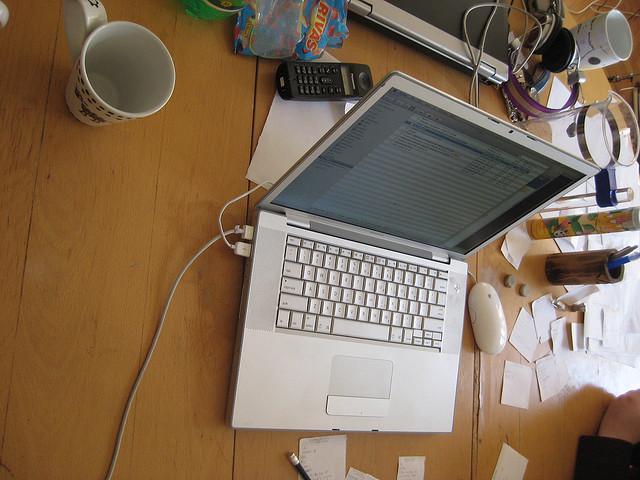How many cups can you see?
Give a very brief answer. 3. 